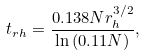Convert formula to latex. <formula><loc_0><loc_0><loc_500><loc_500>t _ { r h } = \frac { 0 . 1 3 8 N r _ { h } ^ { 3 / 2 } } { \ln { ( 0 . 1 1 N ) } } ,</formula> 